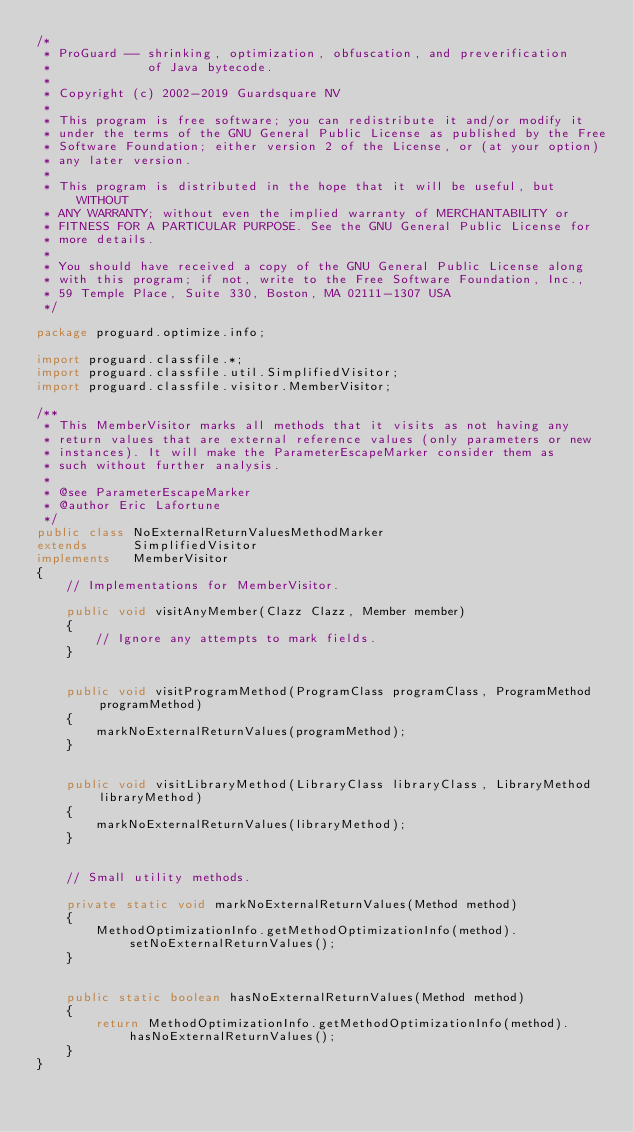Convert code to text. <code><loc_0><loc_0><loc_500><loc_500><_Java_>/*
 * ProGuard -- shrinking, optimization, obfuscation, and preverification
 *             of Java bytecode.
 *
 * Copyright (c) 2002-2019 Guardsquare NV
 *
 * This program is free software; you can redistribute it and/or modify it
 * under the terms of the GNU General Public License as published by the Free
 * Software Foundation; either version 2 of the License, or (at your option)
 * any later version.
 *
 * This program is distributed in the hope that it will be useful, but WITHOUT
 * ANY WARRANTY; without even the implied warranty of MERCHANTABILITY or
 * FITNESS FOR A PARTICULAR PURPOSE. See the GNU General Public License for
 * more details.
 *
 * You should have received a copy of the GNU General Public License along
 * with this program; if not, write to the Free Software Foundation, Inc.,
 * 59 Temple Place, Suite 330, Boston, MA 02111-1307 USA
 */

package proguard.optimize.info;

import proguard.classfile.*;
import proguard.classfile.util.SimplifiedVisitor;
import proguard.classfile.visitor.MemberVisitor;

/**
 * This MemberVisitor marks all methods that it visits as not having any
 * return values that are external reference values (only parameters or new
 * instances). It will make the ParameterEscapeMarker consider them as
 * such without further analysis.
 *
 * @see ParameterEscapeMarker
 * @author Eric Lafortune
 */
public class NoExternalReturnValuesMethodMarker
extends      SimplifiedVisitor
implements   MemberVisitor
{
    // Implementations for MemberVisitor.

    public void visitAnyMember(Clazz Clazz, Member member)
    {
        // Ignore any attempts to mark fields.
    }


    public void visitProgramMethod(ProgramClass programClass, ProgramMethod programMethod)
    {
        markNoExternalReturnValues(programMethod);
    }


    public void visitLibraryMethod(LibraryClass libraryClass, LibraryMethod libraryMethod)
    {
        markNoExternalReturnValues(libraryMethod);
    }


    // Small utility methods.

    private static void markNoExternalReturnValues(Method method)
    {
        MethodOptimizationInfo.getMethodOptimizationInfo(method).setNoExternalReturnValues();
    }


    public static boolean hasNoExternalReturnValues(Method method)
    {
        return MethodOptimizationInfo.getMethodOptimizationInfo(method).hasNoExternalReturnValues();
    }
}
</code> 